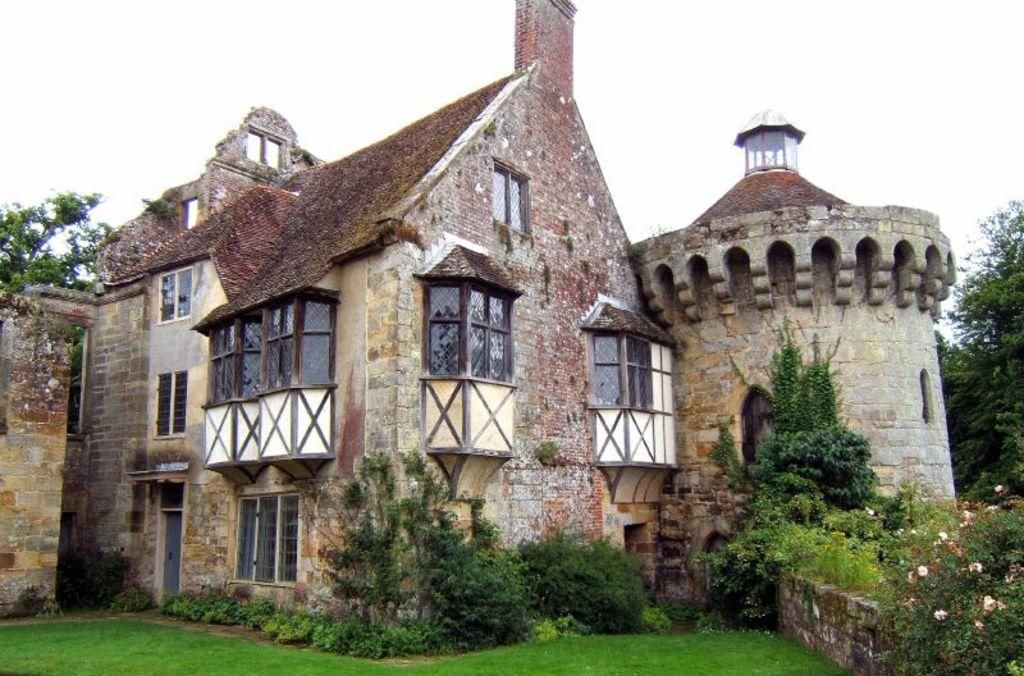What type of structure can be seen in the image? There is a building in the image. What natural elements are present in the image? There are trees, flowers, plants, and grass visible in the image. What is the condition of the sky in the image? The sky is cloudy in the image. Can you see the toes of the person walking on the grass in the image? There is no person or toes visible in the image; it only shows a building, trees, flowers, plants, grass, and a cloudy sky. 